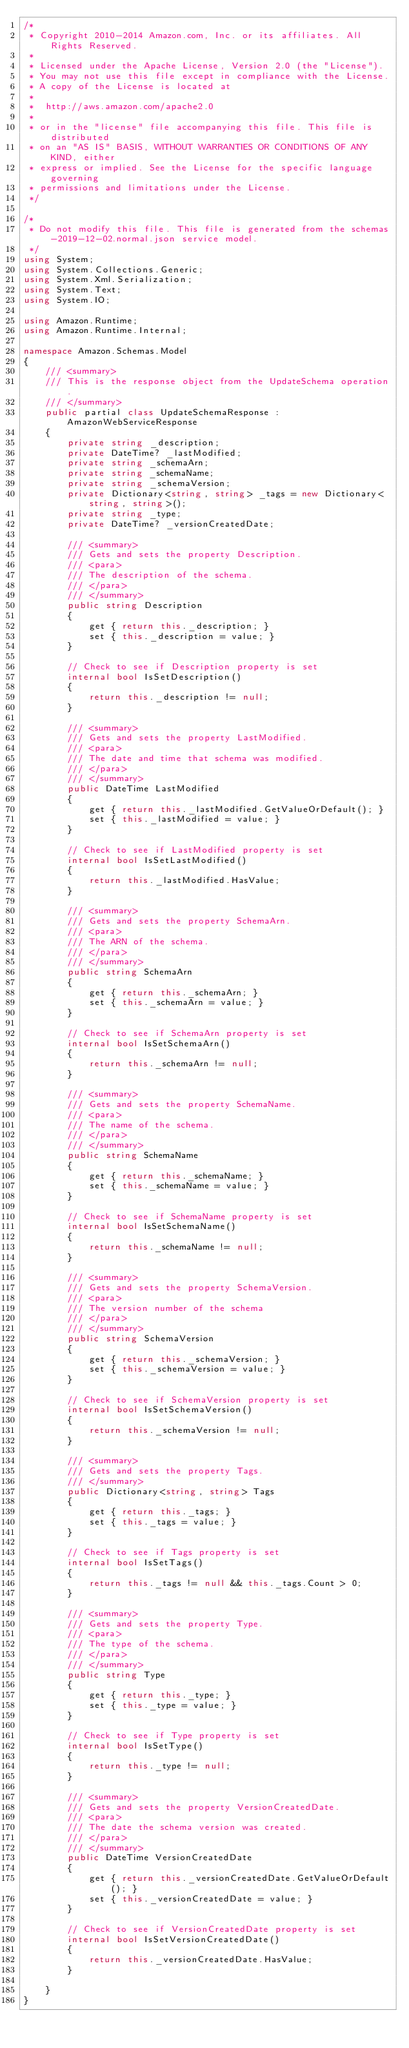Convert code to text. <code><loc_0><loc_0><loc_500><loc_500><_C#_>/*
 * Copyright 2010-2014 Amazon.com, Inc. or its affiliates. All Rights Reserved.
 * 
 * Licensed under the Apache License, Version 2.0 (the "License").
 * You may not use this file except in compliance with the License.
 * A copy of the License is located at
 * 
 *  http://aws.amazon.com/apache2.0
 * 
 * or in the "license" file accompanying this file. This file is distributed
 * on an "AS IS" BASIS, WITHOUT WARRANTIES OR CONDITIONS OF ANY KIND, either
 * express or implied. See the License for the specific language governing
 * permissions and limitations under the License.
 */

/*
 * Do not modify this file. This file is generated from the schemas-2019-12-02.normal.json service model.
 */
using System;
using System.Collections.Generic;
using System.Xml.Serialization;
using System.Text;
using System.IO;

using Amazon.Runtime;
using Amazon.Runtime.Internal;

namespace Amazon.Schemas.Model
{
    /// <summary>
    /// This is the response object from the UpdateSchema operation.
    /// </summary>
    public partial class UpdateSchemaResponse : AmazonWebServiceResponse
    {
        private string _description;
        private DateTime? _lastModified;
        private string _schemaArn;
        private string _schemaName;
        private string _schemaVersion;
        private Dictionary<string, string> _tags = new Dictionary<string, string>();
        private string _type;
        private DateTime? _versionCreatedDate;

        /// <summary>
        /// Gets and sets the property Description. 
        /// <para>
        /// The description of the schema.
        /// </para>
        /// </summary>
        public string Description
        {
            get { return this._description; }
            set { this._description = value; }
        }

        // Check to see if Description property is set
        internal bool IsSetDescription()
        {
            return this._description != null;
        }

        /// <summary>
        /// Gets and sets the property LastModified. 
        /// <para>
        /// The date and time that schema was modified.
        /// </para>
        /// </summary>
        public DateTime LastModified
        {
            get { return this._lastModified.GetValueOrDefault(); }
            set { this._lastModified = value; }
        }

        // Check to see if LastModified property is set
        internal bool IsSetLastModified()
        {
            return this._lastModified.HasValue; 
        }

        /// <summary>
        /// Gets and sets the property SchemaArn. 
        /// <para>
        /// The ARN of the schema.
        /// </para>
        /// </summary>
        public string SchemaArn
        {
            get { return this._schemaArn; }
            set { this._schemaArn = value; }
        }

        // Check to see if SchemaArn property is set
        internal bool IsSetSchemaArn()
        {
            return this._schemaArn != null;
        }

        /// <summary>
        /// Gets and sets the property SchemaName. 
        /// <para>
        /// The name of the schema.
        /// </para>
        /// </summary>
        public string SchemaName
        {
            get { return this._schemaName; }
            set { this._schemaName = value; }
        }

        // Check to see if SchemaName property is set
        internal bool IsSetSchemaName()
        {
            return this._schemaName != null;
        }

        /// <summary>
        /// Gets and sets the property SchemaVersion. 
        /// <para>
        /// The version number of the schema
        /// </para>
        /// </summary>
        public string SchemaVersion
        {
            get { return this._schemaVersion; }
            set { this._schemaVersion = value; }
        }

        // Check to see if SchemaVersion property is set
        internal bool IsSetSchemaVersion()
        {
            return this._schemaVersion != null;
        }

        /// <summary>
        /// Gets and sets the property Tags.
        /// </summary>
        public Dictionary<string, string> Tags
        {
            get { return this._tags; }
            set { this._tags = value; }
        }

        // Check to see if Tags property is set
        internal bool IsSetTags()
        {
            return this._tags != null && this._tags.Count > 0; 
        }

        /// <summary>
        /// Gets and sets the property Type. 
        /// <para>
        /// The type of the schema.
        /// </para>
        /// </summary>
        public string Type
        {
            get { return this._type; }
            set { this._type = value; }
        }

        // Check to see if Type property is set
        internal bool IsSetType()
        {
            return this._type != null;
        }

        /// <summary>
        /// Gets and sets the property VersionCreatedDate. 
        /// <para>
        /// The date the schema version was created.
        /// </para>
        /// </summary>
        public DateTime VersionCreatedDate
        {
            get { return this._versionCreatedDate.GetValueOrDefault(); }
            set { this._versionCreatedDate = value; }
        }

        // Check to see if VersionCreatedDate property is set
        internal bool IsSetVersionCreatedDate()
        {
            return this._versionCreatedDate.HasValue; 
        }

    }
}</code> 